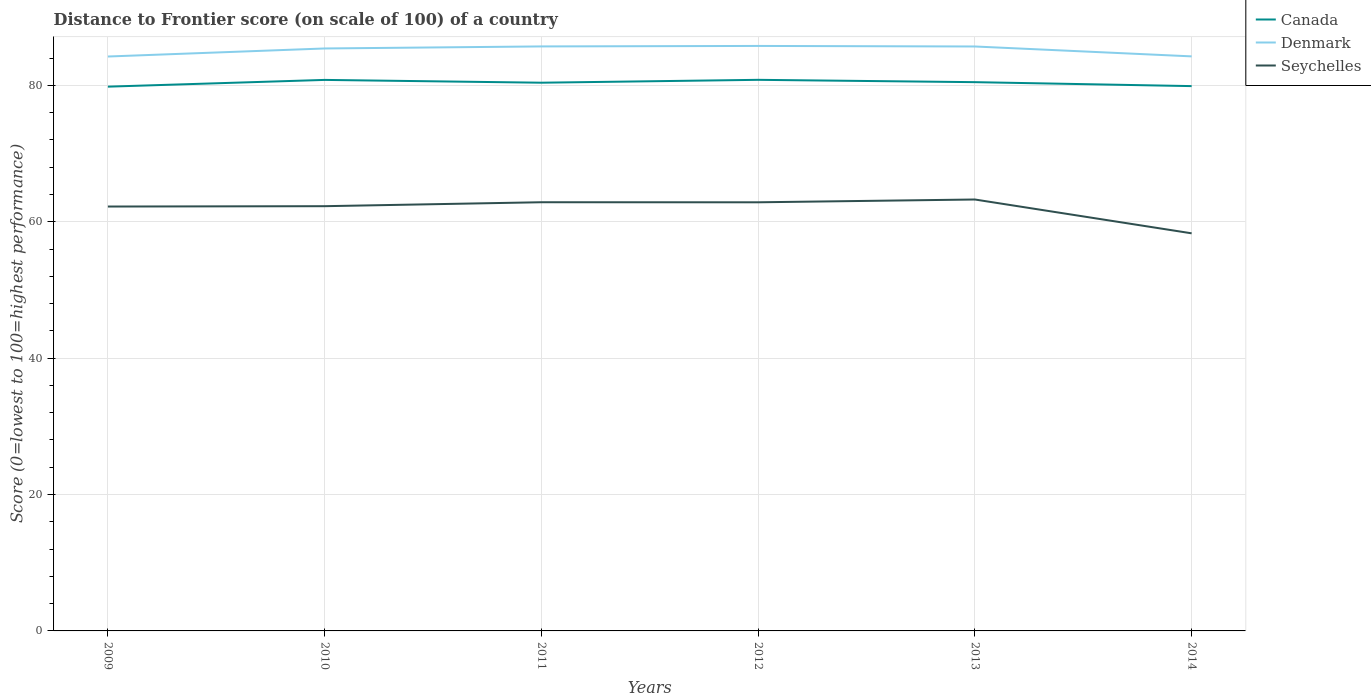How many different coloured lines are there?
Offer a terse response. 3. Is the number of lines equal to the number of legend labels?
Give a very brief answer. Yes. Across all years, what is the maximum distance to frontier score of in Seychelles?
Your response must be concise. 58.31. What is the total distance to frontier score of in Seychelles in the graph?
Provide a short and direct response. -0.05. What is the difference between the highest and the second highest distance to frontier score of in Seychelles?
Offer a terse response. 4.96. How many lines are there?
Provide a short and direct response. 3. How many years are there in the graph?
Ensure brevity in your answer.  6. Are the values on the major ticks of Y-axis written in scientific E-notation?
Offer a very short reply. No. Does the graph contain any zero values?
Keep it short and to the point. No. Does the graph contain grids?
Ensure brevity in your answer.  Yes. How are the legend labels stacked?
Provide a short and direct response. Vertical. What is the title of the graph?
Your answer should be very brief. Distance to Frontier score (on scale of 100) of a country. What is the label or title of the Y-axis?
Your answer should be compact. Score (0=lowest to 100=highest performance). What is the Score (0=lowest to 100=highest performance) of Canada in 2009?
Provide a succinct answer. 79.82. What is the Score (0=lowest to 100=highest performance) of Denmark in 2009?
Your answer should be compact. 84.24. What is the Score (0=lowest to 100=highest performance) in Seychelles in 2009?
Provide a short and direct response. 62.24. What is the Score (0=lowest to 100=highest performance) of Canada in 2010?
Your answer should be very brief. 80.81. What is the Score (0=lowest to 100=highest performance) of Denmark in 2010?
Your answer should be compact. 85.42. What is the Score (0=lowest to 100=highest performance) in Seychelles in 2010?
Your answer should be compact. 62.29. What is the Score (0=lowest to 100=highest performance) in Canada in 2011?
Provide a succinct answer. 80.4. What is the Score (0=lowest to 100=highest performance) of Denmark in 2011?
Ensure brevity in your answer.  85.72. What is the Score (0=lowest to 100=highest performance) in Seychelles in 2011?
Make the answer very short. 62.87. What is the Score (0=lowest to 100=highest performance) in Canada in 2012?
Give a very brief answer. 80.82. What is the Score (0=lowest to 100=highest performance) in Denmark in 2012?
Offer a terse response. 85.79. What is the Score (0=lowest to 100=highest performance) of Seychelles in 2012?
Ensure brevity in your answer.  62.86. What is the Score (0=lowest to 100=highest performance) of Canada in 2013?
Provide a short and direct response. 80.48. What is the Score (0=lowest to 100=highest performance) of Denmark in 2013?
Your response must be concise. 85.71. What is the Score (0=lowest to 100=highest performance) of Seychelles in 2013?
Give a very brief answer. 63.27. What is the Score (0=lowest to 100=highest performance) of Canada in 2014?
Give a very brief answer. 79.9. What is the Score (0=lowest to 100=highest performance) in Denmark in 2014?
Your answer should be compact. 84.26. What is the Score (0=lowest to 100=highest performance) in Seychelles in 2014?
Your answer should be compact. 58.31. Across all years, what is the maximum Score (0=lowest to 100=highest performance) of Canada?
Make the answer very short. 80.82. Across all years, what is the maximum Score (0=lowest to 100=highest performance) of Denmark?
Your response must be concise. 85.79. Across all years, what is the maximum Score (0=lowest to 100=highest performance) in Seychelles?
Your answer should be very brief. 63.27. Across all years, what is the minimum Score (0=lowest to 100=highest performance) in Canada?
Provide a succinct answer. 79.82. Across all years, what is the minimum Score (0=lowest to 100=highest performance) of Denmark?
Give a very brief answer. 84.24. Across all years, what is the minimum Score (0=lowest to 100=highest performance) of Seychelles?
Make the answer very short. 58.31. What is the total Score (0=lowest to 100=highest performance) in Canada in the graph?
Offer a terse response. 482.23. What is the total Score (0=lowest to 100=highest performance) in Denmark in the graph?
Make the answer very short. 511.14. What is the total Score (0=lowest to 100=highest performance) of Seychelles in the graph?
Offer a terse response. 371.84. What is the difference between the Score (0=lowest to 100=highest performance) in Canada in 2009 and that in 2010?
Provide a succinct answer. -0.99. What is the difference between the Score (0=lowest to 100=highest performance) of Denmark in 2009 and that in 2010?
Make the answer very short. -1.18. What is the difference between the Score (0=lowest to 100=highest performance) in Seychelles in 2009 and that in 2010?
Ensure brevity in your answer.  -0.05. What is the difference between the Score (0=lowest to 100=highest performance) of Canada in 2009 and that in 2011?
Offer a very short reply. -0.58. What is the difference between the Score (0=lowest to 100=highest performance) of Denmark in 2009 and that in 2011?
Provide a short and direct response. -1.48. What is the difference between the Score (0=lowest to 100=highest performance) in Seychelles in 2009 and that in 2011?
Make the answer very short. -0.63. What is the difference between the Score (0=lowest to 100=highest performance) of Denmark in 2009 and that in 2012?
Provide a succinct answer. -1.55. What is the difference between the Score (0=lowest to 100=highest performance) of Seychelles in 2009 and that in 2012?
Give a very brief answer. -0.62. What is the difference between the Score (0=lowest to 100=highest performance) in Canada in 2009 and that in 2013?
Make the answer very short. -0.66. What is the difference between the Score (0=lowest to 100=highest performance) of Denmark in 2009 and that in 2013?
Provide a succinct answer. -1.47. What is the difference between the Score (0=lowest to 100=highest performance) of Seychelles in 2009 and that in 2013?
Your answer should be compact. -1.03. What is the difference between the Score (0=lowest to 100=highest performance) of Canada in 2009 and that in 2014?
Your answer should be very brief. -0.08. What is the difference between the Score (0=lowest to 100=highest performance) of Denmark in 2009 and that in 2014?
Keep it short and to the point. -0.02. What is the difference between the Score (0=lowest to 100=highest performance) of Seychelles in 2009 and that in 2014?
Your answer should be very brief. 3.93. What is the difference between the Score (0=lowest to 100=highest performance) of Canada in 2010 and that in 2011?
Your response must be concise. 0.41. What is the difference between the Score (0=lowest to 100=highest performance) in Denmark in 2010 and that in 2011?
Provide a short and direct response. -0.3. What is the difference between the Score (0=lowest to 100=highest performance) in Seychelles in 2010 and that in 2011?
Your answer should be very brief. -0.58. What is the difference between the Score (0=lowest to 100=highest performance) in Canada in 2010 and that in 2012?
Your answer should be compact. -0.01. What is the difference between the Score (0=lowest to 100=highest performance) in Denmark in 2010 and that in 2012?
Keep it short and to the point. -0.37. What is the difference between the Score (0=lowest to 100=highest performance) in Seychelles in 2010 and that in 2012?
Make the answer very short. -0.57. What is the difference between the Score (0=lowest to 100=highest performance) in Canada in 2010 and that in 2013?
Keep it short and to the point. 0.33. What is the difference between the Score (0=lowest to 100=highest performance) in Denmark in 2010 and that in 2013?
Your answer should be very brief. -0.29. What is the difference between the Score (0=lowest to 100=highest performance) of Seychelles in 2010 and that in 2013?
Your answer should be very brief. -0.98. What is the difference between the Score (0=lowest to 100=highest performance) of Canada in 2010 and that in 2014?
Keep it short and to the point. 0.91. What is the difference between the Score (0=lowest to 100=highest performance) of Denmark in 2010 and that in 2014?
Ensure brevity in your answer.  1.16. What is the difference between the Score (0=lowest to 100=highest performance) in Seychelles in 2010 and that in 2014?
Provide a succinct answer. 3.98. What is the difference between the Score (0=lowest to 100=highest performance) in Canada in 2011 and that in 2012?
Your answer should be compact. -0.42. What is the difference between the Score (0=lowest to 100=highest performance) of Denmark in 2011 and that in 2012?
Make the answer very short. -0.07. What is the difference between the Score (0=lowest to 100=highest performance) of Seychelles in 2011 and that in 2012?
Ensure brevity in your answer.  0.01. What is the difference between the Score (0=lowest to 100=highest performance) of Canada in 2011 and that in 2013?
Provide a succinct answer. -0.08. What is the difference between the Score (0=lowest to 100=highest performance) of Canada in 2011 and that in 2014?
Ensure brevity in your answer.  0.5. What is the difference between the Score (0=lowest to 100=highest performance) of Denmark in 2011 and that in 2014?
Offer a very short reply. 1.46. What is the difference between the Score (0=lowest to 100=highest performance) in Seychelles in 2011 and that in 2014?
Provide a succinct answer. 4.56. What is the difference between the Score (0=lowest to 100=highest performance) in Canada in 2012 and that in 2013?
Provide a succinct answer. 0.34. What is the difference between the Score (0=lowest to 100=highest performance) in Seychelles in 2012 and that in 2013?
Provide a short and direct response. -0.41. What is the difference between the Score (0=lowest to 100=highest performance) of Denmark in 2012 and that in 2014?
Keep it short and to the point. 1.53. What is the difference between the Score (0=lowest to 100=highest performance) in Seychelles in 2012 and that in 2014?
Keep it short and to the point. 4.55. What is the difference between the Score (0=lowest to 100=highest performance) of Canada in 2013 and that in 2014?
Give a very brief answer. 0.58. What is the difference between the Score (0=lowest to 100=highest performance) of Denmark in 2013 and that in 2014?
Make the answer very short. 1.45. What is the difference between the Score (0=lowest to 100=highest performance) of Seychelles in 2013 and that in 2014?
Make the answer very short. 4.96. What is the difference between the Score (0=lowest to 100=highest performance) of Canada in 2009 and the Score (0=lowest to 100=highest performance) of Seychelles in 2010?
Provide a succinct answer. 17.53. What is the difference between the Score (0=lowest to 100=highest performance) of Denmark in 2009 and the Score (0=lowest to 100=highest performance) of Seychelles in 2010?
Keep it short and to the point. 21.95. What is the difference between the Score (0=lowest to 100=highest performance) of Canada in 2009 and the Score (0=lowest to 100=highest performance) of Seychelles in 2011?
Offer a very short reply. 16.95. What is the difference between the Score (0=lowest to 100=highest performance) in Denmark in 2009 and the Score (0=lowest to 100=highest performance) in Seychelles in 2011?
Your answer should be compact. 21.37. What is the difference between the Score (0=lowest to 100=highest performance) in Canada in 2009 and the Score (0=lowest to 100=highest performance) in Denmark in 2012?
Your answer should be very brief. -5.97. What is the difference between the Score (0=lowest to 100=highest performance) in Canada in 2009 and the Score (0=lowest to 100=highest performance) in Seychelles in 2012?
Provide a succinct answer. 16.96. What is the difference between the Score (0=lowest to 100=highest performance) of Denmark in 2009 and the Score (0=lowest to 100=highest performance) of Seychelles in 2012?
Provide a succinct answer. 21.38. What is the difference between the Score (0=lowest to 100=highest performance) in Canada in 2009 and the Score (0=lowest to 100=highest performance) in Denmark in 2013?
Ensure brevity in your answer.  -5.89. What is the difference between the Score (0=lowest to 100=highest performance) in Canada in 2009 and the Score (0=lowest to 100=highest performance) in Seychelles in 2013?
Your answer should be very brief. 16.55. What is the difference between the Score (0=lowest to 100=highest performance) of Denmark in 2009 and the Score (0=lowest to 100=highest performance) of Seychelles in 2013?
Your answer should be very brief. 20.97. What is the difference between the Score (0=lowest to 100=highest performance) of Canada in 2009 and the Score (0=lowest to 100=highest performance) of Denmark in 2014?
Your answer should be very brief. -4.44. What is the difference between the Score (0=lowest to 100=highest performance) in Canada in 2009 and the Score (0=lowest to 100=highest performance) in Seychelles in 2014?
Keep it short and to the point. 21.51. What is the difference between the Score (0=lowest to 100=highest performance) in Denmark in 2009 and the Score (0=lowest to 100=highest performance) in Seychelles in 2014?
Give a very brief answer. 25.93. What is the difference between the Score (0=lowest to 100=highest performance) in Canada in 2010 and the Score (0=lowest to 100=highest performance) in Denmark in 2011?
Give a very brief answer. -4.91. What is the difference between the Score (0=lowest to 100=highest performance) of Canada in 2010 and the Score (0=lowest to 100=highest performance) of Seychelles in 2011?
Give a very brief answer. 17.94. What is the difference between the Score (0=lowest to 100=highest performance) in Denmark in 2010 and the Score (0=lowest to 100=highest performance) in Seychelles in 2011?
Provide a short and direct response. 22.55. What is the difference between the Score (0=lowest to 100=highest performance) in Canada in 2010 and the Score (0=lowest to 100=highest performance) in Denmark in 2012?
Provide a succinct answer. -4.98. What is the difference between the Score (0=lowest to 100=highest performance) of Canada in 2010 and the Score (0=lowest to 100=highest performance) of Seychelles in 2012?
Offer a terse response. 17.95. What is the difference between the Score (0=lowest to 100=highest performance) of Denmark in 2010 and the Score (0=lowest to 100=highest performance) of Seychelles in 2012?
Your answer should be very brief. 22.56. What is the difference between the Score (0=lowest to 100=highest performance) in Canada in 2010 and the Score (0=lowest to 100=highest performance) in Seychelles in 2013?
Give a very brief answer. 17.54. What is the difference between the Score (0=lowest to 100=highest performance) of Denmark in 2010 and the Score (0=lowest to 100=highest performance) of Seychelles in 2013?
Provide a short and direct response. 22.15. What is the difference between the Score (0=lowest to 100=highest performance) in Canada in 2010 and the Score (0=lowest to 100=highest performance) in Denmark in 2014?
Provide a succinct answer. -3.45. What is the difference between the Score (0=lowest to 100=highest performance) in Denmark in 2010 and the Score (0=lowest to 100=highest performance) in Seychelles in 2014?
Ensure brevity in your answer.  27.11. What is the difference between the Score (0=lowest to 100=highest performance) in Canada in 2011 and the Score (0=lowest to 100=highest performance) in Denmark in 2012?
Ensure brevity in your answer.  -5.39. What is the difference between the Score (0=lowest to 100=highest performance) of Canada in 2011 and the Score (0=lowest to 100=highest performance) of Seychelles in 2012?
Your answer should be very brief. 17.54. What is the difference between the Score (0=lowest to 100=highest performance) of Denmark in 2011 and the Score (0=lowest to 100=highest performance) of Seychelles in 2012?
Make the answer very short. 22.86. What is the difference between the Score (0=lowest to 100=highest performance) of Canada in 2011 and the Score (0=lowest to 100=highest performance) of Denmark in 2013?
Your answer should be compact. -5.31. What is the difference between the Score (0=lowest to 100=highest performance) in Canada in 2011 and the Score (0=lowest to 100=highest performance) in Seychelles in 2013?
Provide a short and direct response. 17.13. What is the difference between the Score (0=lowest to 100=highest performance) of Denmark in 2011 and the Score (0=lowest to 100=highest performance) of Seychelles in 2013?
Give a very brief answer. 22.45. What is the difference between the Score (0=lowest to 100=highest performance) in Canada in 2011 and the Score (0=lowest to 100=highest performance) in Denmark in 2014?
Ensure brevity in your answer.  -3.86. What is the difference between the Score (0=lowest to 100=highest performance) of Canada in 2011 and the Score (0=lowest to 100=highest performance) of Seychelles in 2014?
Your response must be concise. 22.09. What is the difference between the Score (0=lowest to 100=highest performance) of Denmark in 2011 and the Score (0=lowest to 100=highest performance) of Seychelles in 2014?
Offer a very short reply. 27.41. What is the difference between the Score (0=lowest to 100=highest performance) in Canada in 2012 and the Score (0=lowest to 100=highest performance) in Denmark in 2013?
Your answer should be very brief. -4.89. What is the difference between the Score (0=lowest to 100=highest performance) in Canada in 2012 and the Score (0=lowest to 100=highest performance) in Seychelles in 2013?
Offer a terse response. 17.55. What is the difference between the Score (0=lowest to 100=highest performance) in Denmark in 2012 and the Score (0=lowest to 100=highest performance) in Seychelles in 2013?
Give a very brief answer. 22.52. What is the difference between the Score (0=lowest to 100=highest performance) of Canada in 2012 and the Score (0=lowest to 100=highest performance) of Denmark in 2014?
Provide a succinct answer. -3.44. What is the difference between the Score (0=lowest to 100=highest performance) in Canada in 2012 and the Score (0=lowest to 100=highest performance) in Seychelles in 2014?
Provide a succinct answer. 22.51. What is the difference between the Score (0=lowest to 100=highest performance) in Denmark in 2012 and the Score (0=lowest to 100=highest performance) in Seychelles in 2014?
Give a very brief answer. 27.48. What is the difference between the Score (0=lowest to 100=highest performance) of Canada in 2013 and the Score (0=lowest to 100=highest performance) of Denmark in 2014?
Make the answer very short. -3.78. What is the difference between the Score (0=lowest to 100=highest performance) in Canada in 2013 and the Score (0=lowest to 100=highest performance) in Seychelles in 2014?
Make the answer very short. 22.17. What is the difference between the Score (0=lowest to 100=highest performance) of Denmark in 2013 and the Score (0=lowest to 100=highest performance) of Seychelles in 2014?
Provide a succinct answer. 27.4. What is the average Score (0=lowest to 100=highest performance) in Canada per year?
Provide a succinct answer. 80.37. What is the average Score (0=lowest to 100=highest performance) in Denmark per year?
Keep it short and to the point. 85.19. What is the average Score (0=lowest to 100=highest performance) of Seychelles per year?
Give a very brief answer. 61.97. In the year 2009, what is the difference between the Score (0=lowest to 100=highest performance) of Canada and Score (0=lowest to 100=highest performance) of Denmark?
Give a very brief answer. -4.42. In the year 2009, what is the difference between the Score (0=lowest to 100=highest performance) in Canada and Score (0=lowest to 100=highest performance) in Seychelles?
Keep it short and to the point. 17.58. In the year 2009, what is the difference between the Score (0=lowest to 100=highest performance) in Denmark and Score (0=lowest to 100=highest performance) in Seychelles?
Make the answer very short. 22. In the year 2010, what is the difference between the Score (0=lowest to 100=highest performance) in Canada and Score (0=lowest to 100=highest performance) in Denmark?
Your answer should be compact. -4.61. In the year 2010, what is the difference between the Score (0=lowest to 100=highest performance) in Canada and Score (0=lowest to 100=highest performance) in Seychelles?
Offer a very short reply. 18.52. In the year 2010, what is the difference between the Score (0=lowest to 100=highest performance) in Denmark and Score (0=lowest to 100=highest performance) in Seychelles?
Keep it short and to the point. 23.13. In the year 2011, what is the difference between the Score (0=lowest to 100=highest performance) in Canada and Score (0=lowest to 100=highest performance) in Denmark?
Make the answer very short. -5.32. In the year 2011, what is the difference between the Score (0=lowest to 100=highest performance) of Canada and Score (0=lowest to 100=highest performance) of Seychelles?
Ensure brevity in your answer.  17.53. In the year 2011, what is the difference between the Score (0=lowest to 100=highest performance) in Denmark and Score (0=lowest to 100=highest performance) in Seychelles?
Give a very brief answer. 22.85. In the year 2012, what is the difference between the Score (0=lowest to 100=highest performance) of Canada and Score (0=lowest to 100=highest performance) of Denmark?
Provide a short and direct response. -4.97. In the year 2012, what is the difference between the Score (0=lowest to 100=highest performance) of Canada and Score (0=lowest to 100=highest performance) of Seychelles?
Keep it short and to the point. 17.96. In the year 2012, what is the difference between the Score (0=lowest to 100=highest performance) in Denmark and Score (0=lowest to 100=highest performance) in Seychelles?
Your answer should be very brief. 22.93. In the year 2013, what is the difference between the Score (0=lowest to 100=highest performance) in Canada and Score (0=lowest to 100=highest performance) in Denmark?
Offer a terse response. -5.23. In the year 2013, what is the difference between the Score (0=lowest to 100=highest performance) of Canada and Score (0=lowest to 100=highest performance) of Seychelles?
Keep it short and to the point. 17.21. In the year 2013, what is the difference between the Score (0=lowest to 100=highest performance) of Denmark and Score (0=lowest to 100=highest performance) of Seychelles?
Your response must be concise. 22.44. In the year 2014, what is the difference between the Score (0=lowest to 100=highest performance) in Canada and Score (0=lowest to 100=highest performance) in Denmark?
Offer a terse response. -4.36. In the year 2014, what is the difference between the Score (0=lowest to 100=highest performance) of Canada and Score (0=lowest to 100=highest performance) of Seychelles?
Provide a short and direct response. 21.59. In the year 2014, what is the difference between the Score (0=lowest to 100=highest performance) in Denmark and Score (0=lowest to 100=highest performance) in Seychelles?
Your answer should be very brief. 25.95. What is the ratio of the Score (0=lowest to 100=highest performance) in Canada in 2009 to that in 2010?
Provide a short and direct response. 0.99. What is the ratio of the Score (0=lowest to 100=highest performance) of Denmark in 2009 to that in 2010?
Offer a terse response. 0.99. What is the ratio of the Score (0=lowest to 100=highest performance) of Denmark in 2009 to that in 2011?
Keep it short and to the point. 0.98. What is the ratio of the Score (0=lowest to 100=highest performance) of Seychelles in 2009 to that in 2011?
Provide a succinct answer. 0.99. What is the ratio of the Score (0=lowest to 100=highest performance) in Canada in 2009 to that in 2012?
Provide a succinct answer. 0.99. What is the ratio of the Score (0=lowest to 100=highest performance) in Denmark in 2009 to that in 2012?
Provide a succinct answer. 0.98. What is the ratio of the Score (0=lowest to 100=highest performance) of Seychelles in 2009 to that in 2012?
Offer a very short reply. 0.99. What is the ratio of the Score (0=lowest to 100=highest performance) of Canada in 2009 to that in 2013?
Ensure brevity in your answer.  0.99. What is the ratio of the Score (0=lowest to 100=highest performance) in Denmark in 2009 to that in 2013?
Your answer should be very brief. 0.98. What is the ratio of the Score (0=lowest to 100=highest performance) in Seychelles in 2009 to that in 2013?
Ensure brevity in your answer.  0.98. What is the ratio of the Score (0=lowest to 100=highest performance) in Seychelles in 2009 to that in 2014?
Make the answer very short. 1.07. What is the ratio of the Score (0=lowest to 100=highest performance) in Denmark in 2010 to that in 2011?
Keep it short and to the point. 1. What is the ratio of the Score (0=lowest to 100=highest performance) of Seychelles in 2010 to that in 2011?
Your answer should be very brief. 0.99. What is the ratio of the Score (0=lowest to 100=highest performance) in Canada in 2010 to that in 2012?
Provide a succinct answer. 1. What is the ratio of the Score (0=lowest to 100=highest performance) in Seychelles in 2010 to that in 2012?
Your answer should be very brief. 0.99. What is the ratio of the Score (0=lowest to 100=highest performance) in Canada in 2010 to that in 2013?
Your answer should be very brief. 1. What is the ratio of the Score (0=lowest to 100=highest performance) of Seychelles in 2010 to that in 2013?
Keep it short and to the point. 0.98. What is the ratio of the Score (0=lowest to 100=highest performance) in Canada in 2010 to that in 2014?
Your answer should be compact. 1.01. What is the ratio of the Score (0=lowest to 100=highest performance) in Denmark in 2010 to that in 2014?
Give a very brief answer. 1.01. What is the ratio of the Score (0=lowest to 100=highest performance) in Seychelles in 2010 to that in 2014?
Your answer should be very brief. 1.07. What is the ratio of the Score (0=lowest to 100=highest performance) of Canada in 2011 to that in 2012?
Provide a succinct answer. 0.99. What is the ratio of the Score (0=lowest to 100=highest performance) of Denmark in 2011 to that in 2012?
Provide a short and direct response. 1. What is the ratio of the Score (0=lowest to 100=highest performance) in Seychelles in 2011 to that in 2012?
Offer a terse response. 1. What is the ratio of the Score (0=lowest to 100=highest performance) of Seychelles in 2011 to that in 2013?
Offer a very short reply. 0.99. What is the ratio of the Score (0=lowest to 100=highest performance) in Canada in 2011 to that in 2014?
Make the answer very short. 1.01. What is the ratio of the Score (0=lowest to 100=highest performance) in Denmark in 2011 to that in 2014?
Your response must be concise. 1.02. What is the ratio of the Score (0=lowest to 100=highest performance) in Seychelles in 2011 to that in 2014?
Ensure brevity in your answer.  1.08. What is the ratio of the Score (0=lowest to 100=highest performance) of Canada in 2012 to that in 2014?
Offer a terse response. 1.01. What is the ratio of the Score (0=lowest to 100=highest performance) in Denmark in 2012 to that in 2014?
Your answer should be compact. 1.02. What is the ratio of the Score (0=lowest to 100=highest performance) of Seychelles in 2012 to that in 2014?
Your answer should be very brief. 1.08. What is the ratio of the Score (0=lowest to 100=highest performance) in Canada in 2013 to that in 2014?
Provide a short and direct response. 1.01. What is the ratio of the Score (0=lowest to 100=highest performance) in Denmark in 2013 to that in 2014?
Your answer should be compact. 1.02. What is the ratio of the Score (0=lowest to 100=highest performance) in Seychelles in 2013 to that in 2014?
Your response must be concise. 1.09. What is the difference between the highest and the second highest Score (0=lowest to 100=highest performance) of Denmark?
Offer a very short reply. 0.07. What is the difference between the highest and the second highest Score (0=lowest to 100=highest performance) of Seychelles?
Ensure brevity in your answer.  0.4. What is the difference between the highest and the lowest Score (0=lowest to 100=highest performance) in Denmark?
Provide a short and direct response. 1.55. What is the difference between the highest and the lowest Score (0=lowest to 100=highest performance) in Seychelles?
Give a very brief answer. 4.96. 